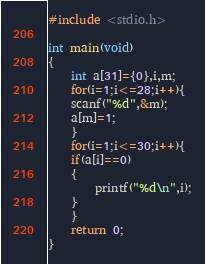<code> <loc_0><loc_0><loc_500><loc_500><_C_>#include <stdio.h>

int main(void)
{
	int a[31]={0},i,m;
	for(i=1;i<=28;i++){
	scanf("%d",&m);
	a[m]=1;
	}
	for(i=1;i<=30;i++){
	if(a[i]==0)
	{
		printf("%d\n",i);
	}
	}
	return 0;
}
</code> 